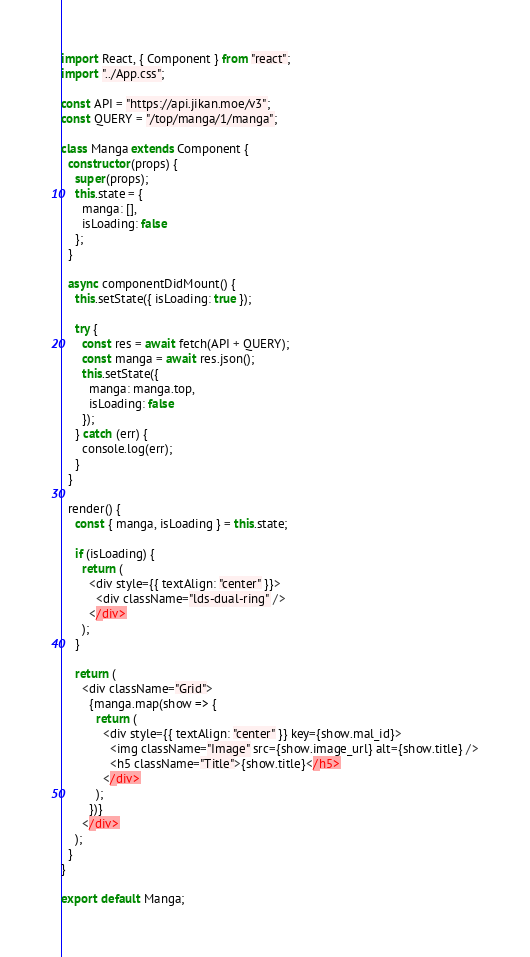<code> <loc_0><loc_0><loc_500><loc_500><_JavaScript_>import React, { Component } from "react";
import "../App.css";

const API = "https://api.jikan.moe/v3";
const QUERY = "/top/manga/1/manga";

class Manga extends Component {
  constructor(props) {
    super(props);
    this.state = {
      manga: [],
      isLoading: false
    };
  }

  async componentDidMount() {
    this.setState({ isLoading: true });

    try {
      const res = await fetch(API + QUERY);
      const manga = await res.json();
      this.setState({
        manga: manga.top,
        isLoading: false
      });
    } catch (err) {
      console.log(err);
    }
  }

  render() {
    const { manga, isLoading } = this.state;

    if (isLoading) {
      return (
        <div style={{ textAlign: "center" }}>
          <div className="lds-dual-ring" />
        </div>
      );
    }

    return (
      <div className="Grid">
        {manga.map(show => {
          return (
            <div style={{ textAlign: "center" }} key={show.mal_id}>
              <img className="Image" src={show.image_url} alt={show.title} />
              <h5 className="Title">{show.title}</h5>
            </div>
          );
        })}
      </div>
    );
  }
}

export default Manga;
</code> 